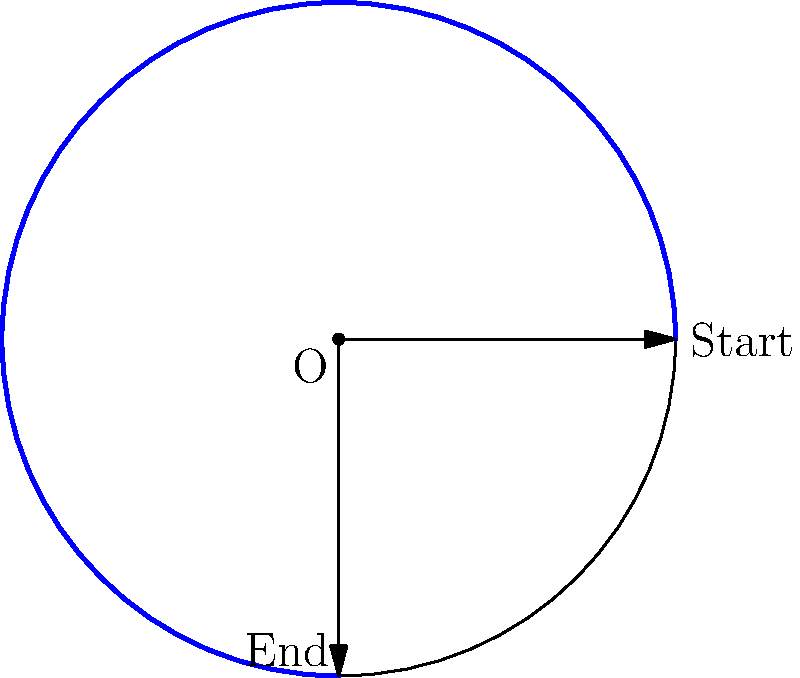You're setting up to take a panoramic shot of the robotics club's workspace. The camera needs to rotate clockwise from its starting position to its end position as shown in the diagram. What is the angle of rotation in degrees? To determine the angle of rotation for the panoramic shot, we need to follow these steps:

1. Identify the starting and ending positions of the camera rotation on the circular path.
2. Observe that the rotation is clockwise from the starting point to the ending point.
3. Recognize that a full circle contains 360°.
4. Notice that the blue arc represents the angle of rotation.
5. The blue arc covers 3/4 of the full circle.
6. Calculate the angle:
   $$\text{Angle of rotation} = \frac{3}{4} \times 360° = 270°$$

Therefore, the camera needs to rotate 270° clockwise to capture the full panoramic shot of the robotics club's workspace.
Answer: 270° 